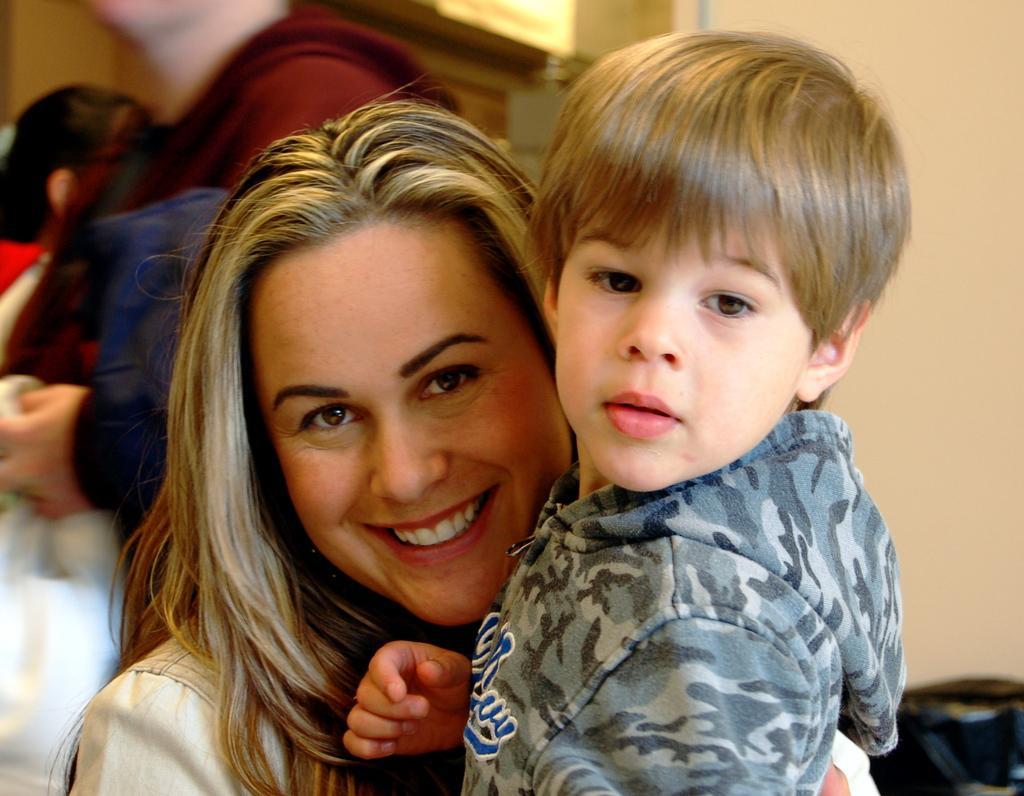Can you describe this image briefly? In this image I can see a woman and a boy. I can see she is wearing white dress and he is wearing hoodie. I can also see smile on her face and I can see in background few more people. I can also see this image is little bit blurry from background. 